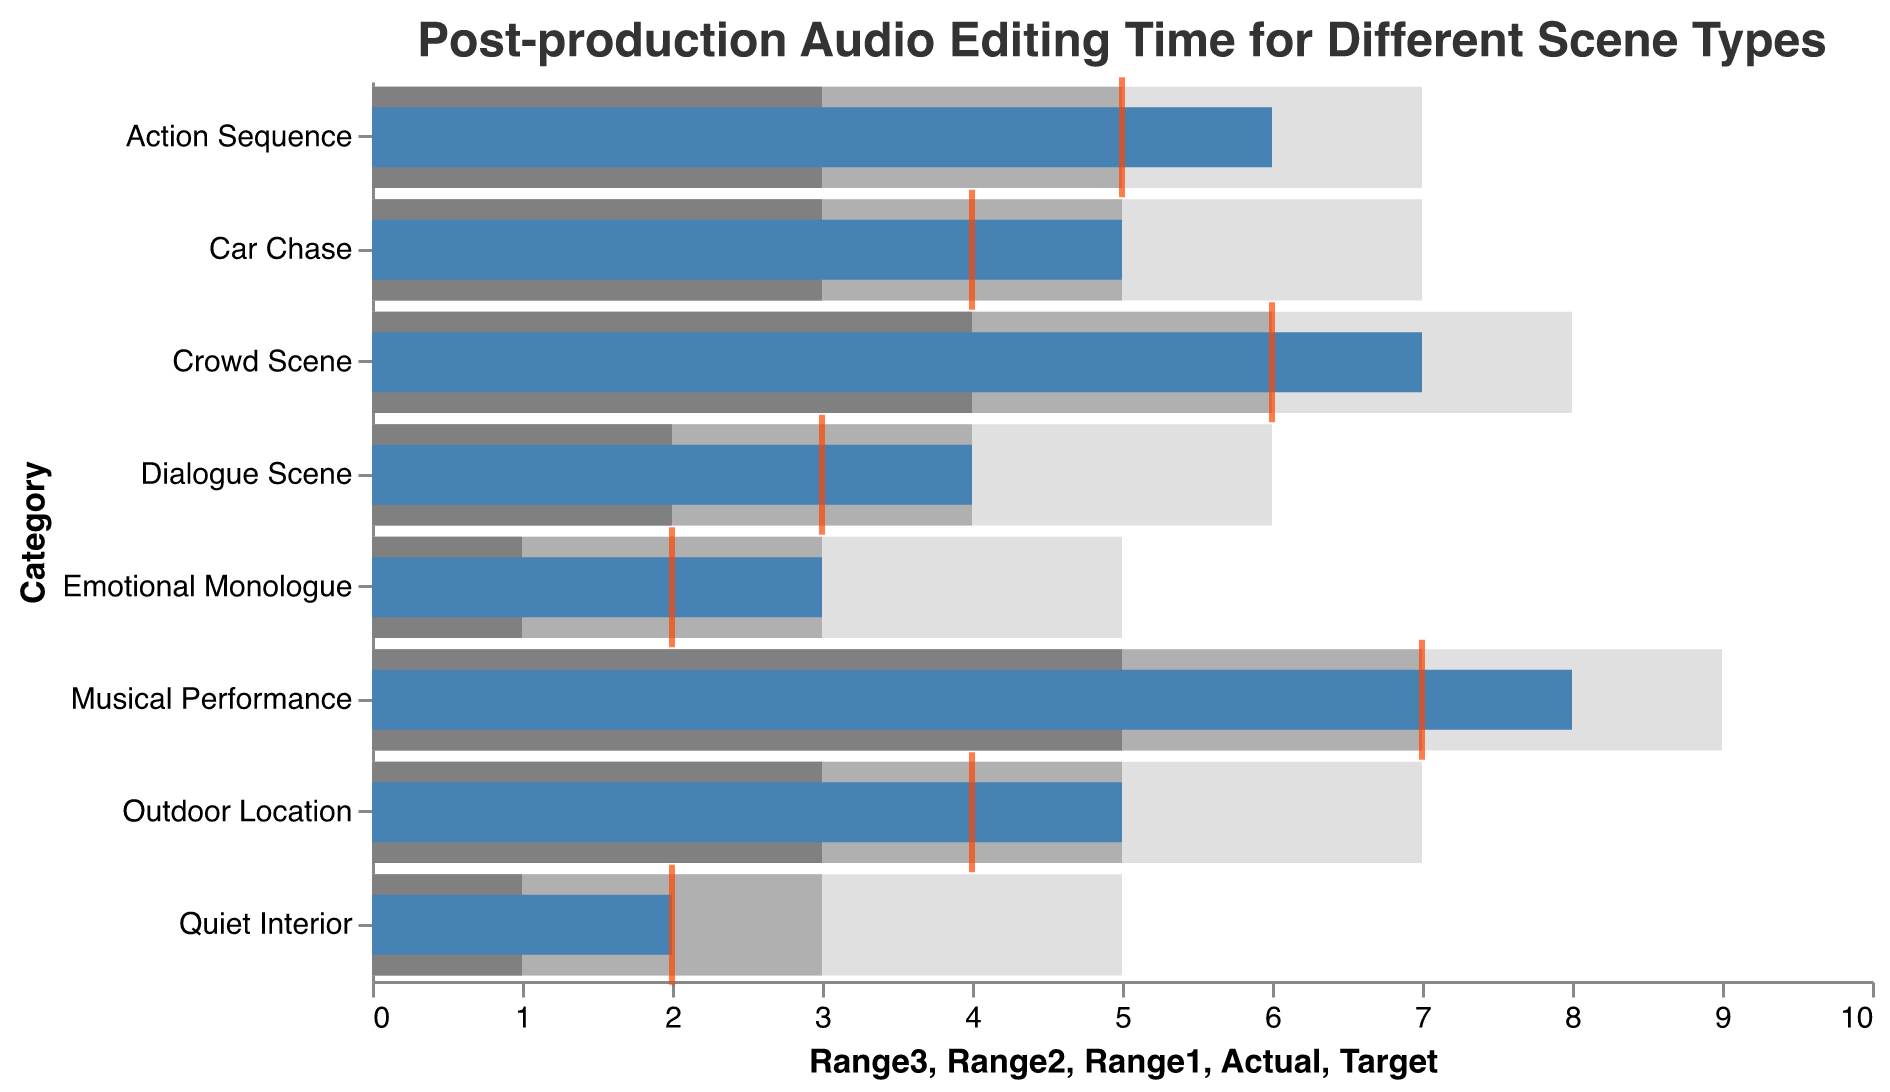What is the maximum target time for any category? Look at the target times represented by the orange ticks and identify the highest value. The highest target value is 7 for Musical Performance.
Answer: 7 Which scene type has the smallest range1 value? Check the lightest grey bars (Range1) for each category and find the smallest value. Emotional Monologue and Quiet Interior both have a range1 value of 1.
Answer: Emotional Monologue or Quiet Interior How many scene types have an actual time exceeding their target time? Compare the Actual times (blue bars) to Target times (orange ticks) for each category and count how many actual times exceed their target times. There are 7 categories where the actual time exceeds the target: Dialogue Scene, Action Sequence, Musical Performance, Outdoor Location, Crowd Scene, Car Chase, and Emotional Monologue.
Answer: 7 For which scene types are the actual and target times equal? Verify which categories have the blue bar end exactly at the orange tick. The Quiet Interior has both actual and target times equal at 2.
Answer: Quiet Interior Is the average target time below 5? Sum all target times and divide by the number of scene types. (3 + 5 + 7 + 4 + 6 + 2 + 4 + 2) / 8 = 33 / 8 = 4.125, which is indeed below 5.
Answer: Yes What is the range of editing times for Musical Performance? Observe the starting value of Range1 and the ending value of Range3 for Musical Performance. The range is from 5 to 9.
Answer: 5 to 9 Which scene type has the widest range for post-production audio editing? Calculate the range (Range3 - Range1) for each category and find the maximum. Musical Performance has the widest range from 5 to 9, which is 4 units.
Answer: Musical Performance Which scene type has the smallest actual editing time? Look at the lengths of the blue bars (Actual times) and identify the smallest. The Quiet Interior has the smallest actual time of 2.
Answer: Quiet Interior What is the difference between the actual and target times for the Car Chase scene type? Subtract the target time from the actual time for Car Chase. The actual time is 5 and the target time is 4, so the difference is 5 - 4 = 1.
Answer: 1 Do any scene types have their actual editing time within the second range value? Assess the Actual values (blue bars) to see if they fall within their corresponding second range value (medium grey). No category has its actual time within the second range.
Answer: No 